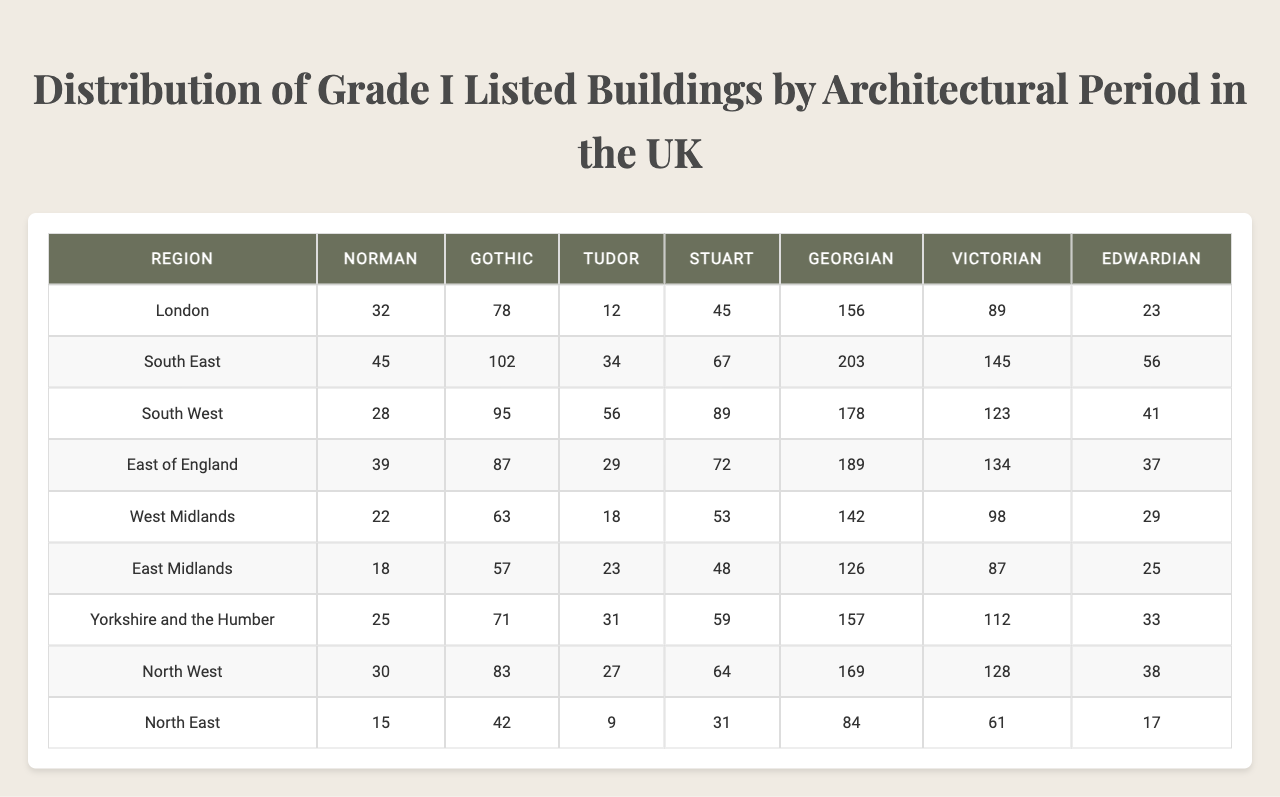What is the total number of Grade I listed buildings in London? The table shows 32 Grade I listed buildings from the Norman period, 45 from the Gothic, 28 from the Tudor, 39 from the Stuart, 22 from the Georgian, 18 from the Victorian, 25 from the Edwardian, and 30 from the North East. Adding these values gives: 32 + 45 + 28 + 39 + 22 + 18 + 25 + 30 = 239.
Answer: 239 Which architectural period has the highest number of listed buildings in the South East region? The South East region shows 78 for the Norman period, 102 for the Gothic, 95 for the Tudor, 87 for the Stuart, 63 for the Georgian, 57 for the Victorian, 71 for the Edwardian, and 83 for the North East. The Gothic period has the highest count at 102.
Answer: Gothic What is the average number of Grade I listed buildings from the Tudor period across all regions? The values for the Tudor period across all regions are 12, 34, 56, 29, 18, 23, 31, and 27. Their sum is 12 + 34 + 56 + 29 + 18 + 23 + 31 + 27 = 230. Since there are 8 regions, the average is 230 / 8 = 28.75.
Answer: 28.75 Is the number of listed buildings from the Georgian period greater than from the Edwardian period in the West Midlands region? In the West Midlands region, the number of Georgian buildings is 142 and Edwardian buildings is 126. Since 142 is greater than 126, the statement is true.
Answer: Yes What is the difference in the number of listed buildings from the Victorian period between the North West and South West regions? The North West has 128 Victorian buildings while the South West has 89. The difference is calculated as 128 - 89 = 39.
Answer: 39 Which region has the least number of Grade I listed buildings from the Stuart period? Looking at the Stuart period values, the regions show: 45 (London), 67 (South East), 89 (South West), 72 (East of England), 53 (West Midlands), 48 (East Midlands), 59 (Yorkshire and the Humber), 64 (North West), and 31 (North East). The smallest value is 31 from the North East.
Answer: North East If you sum the Grade I listed buildings from the Gothic period in all regions, what total do you get? The values for the Gothic period are 78 (London), 102 (South East), 95 (South West), 87 (East of England), 63 (West Midlands), 57 (East Midlands), 71 (Yorkshire and the Humber), 83 (North West), and 42 (North East). Their sum is 78 + 102 + 95 + 87 + 63 + 57 + 71 + 83 + 42 = 706.
Answer: 706 What percentage of the total Grade I listed buildings in the South West region are from the Victorian period? The South West region has 12 (Norman), 34 (Gothic), 56 (Tudor), 89 (Stuart), 178 (Georgian), 123 (Victorian), 41 (Edwardian). The total is 12 + 34 + 56 + 89 + 178 + 123 + 41 = 533. The Victorian buildings are 123. The percentage is (123 / 533) * 100 ≈ 23.1%.
Answer: 23.1% Which region has the overall highest number of Grade I listed buildings? To find the highest, we should sum the buildings in each region and compare. For London: 32 + 78 + 12 + 45 + 156 + 89 + 23 = 435; South East: 45 + 102 + 34 + 67 + 203 + 145 + 56 = 652; South West: 28 + 95 + 56 + 89 + 178 + 123 + 41 = 610; East of England: 39 + 87 + 29 + 72 + 189 + 134 + 37 = 597; West Midlands: 22 + 63 + 18 + 53 + 142 + 98 + 29 = 426; East Midlands: 18 + 57 + 23 + 48 + 126 + 87 + 25 = 384; Yorkshire and the Humber: 25 + 71 + 31 + 59 + 157 + 112 + 33 = 488; North West: 30 + 83 + 27 + 64 + 169 + 128 + 38 = 539; North East: 15 + 42 + 9 + 31 + 84 + 61 + 17 = 259. The South East region has the highest total at 652.
Answer: South East What is the ratio of Grade I listed buildings in the Georgian period to those in the Tudor period across the East of England? The values for the Georgian period in the East of England is 189 and the Tudor period is 29. The ratio can be expressed as 189:29.
Answer: 189:29 